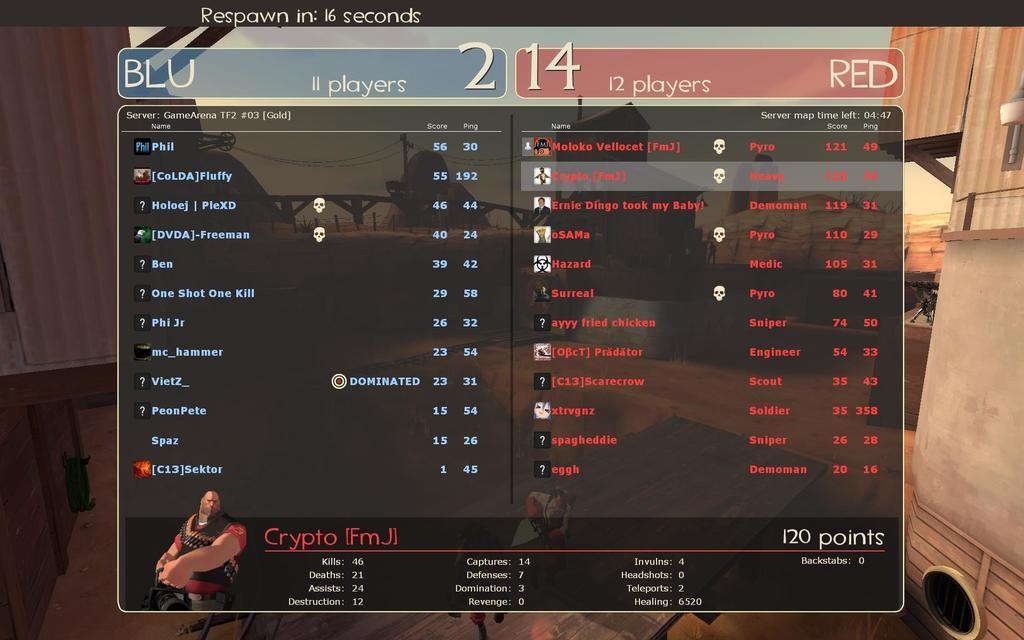Provide a one-sentence caption for the provided image. A video game screen shows that team Blu has 11 players and team Red has 12 players. 